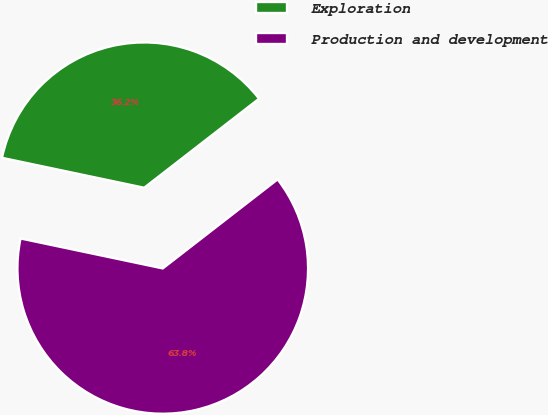Convert chart. <chart><loc_0><loc_0><loc_500><loc_500><pie_chart><fcel>Exploration<fcel>Production and development<nl><fcel>36.2%<fcel>63.8%<nl></chart> 